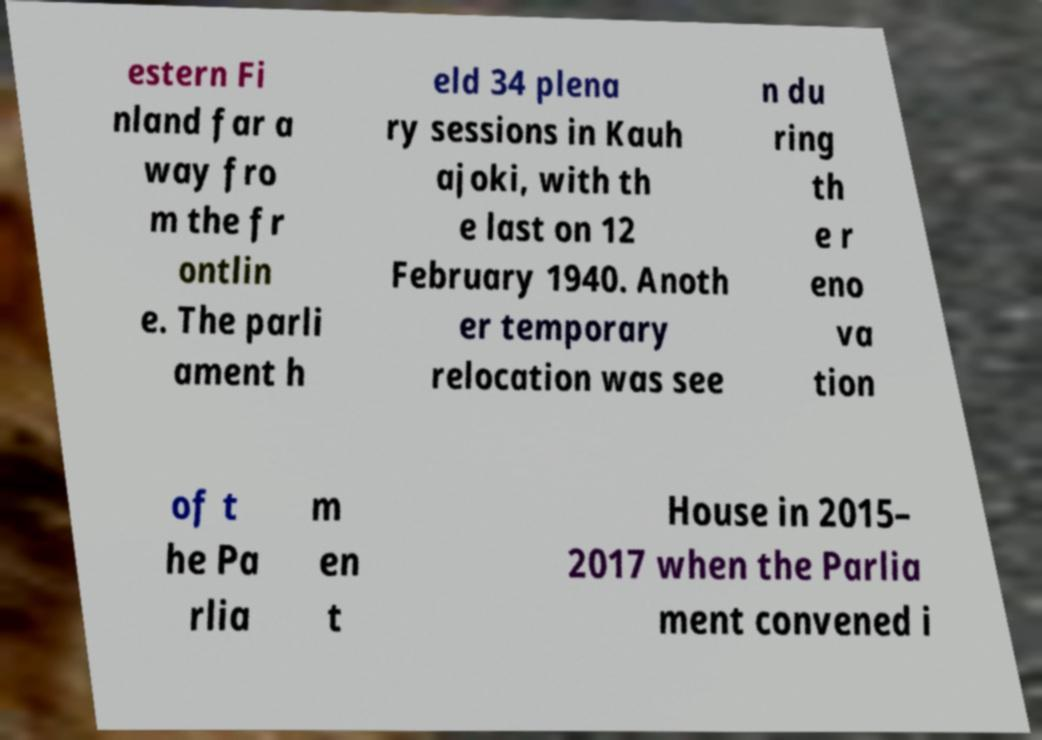Please identify and transcribe the text found in this image. estern Fi nland far a way fro m the fr ontlin e. The parli ament h eld 34 plena ry sessions in Kauh ajoki, with th e last on 12 February 1940. Anoth er temporary relocation was see n du ring th e r eno va tion of t he Pa rlia m en t House in 2015– 2017 when the Parlia ment convened i 